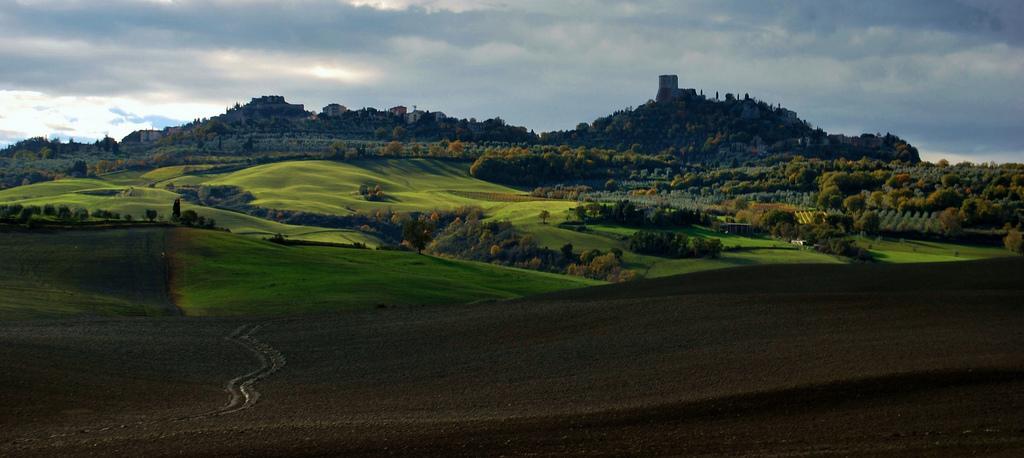How would you summarize this image in a sentence or two? In this image there is a grassland, trees, mountains and the sky. 